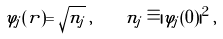Convert formula to latex. <formula><loc_0><loc_0><loc_500><loc_500>\varphi _ { j } ( { r } ) = \sqrt { n _ { j } } \, , \quad n _ { j } \equiv | \varphi _ { j } ( 0 ) | ^ { 2 } \, ,</formula> 